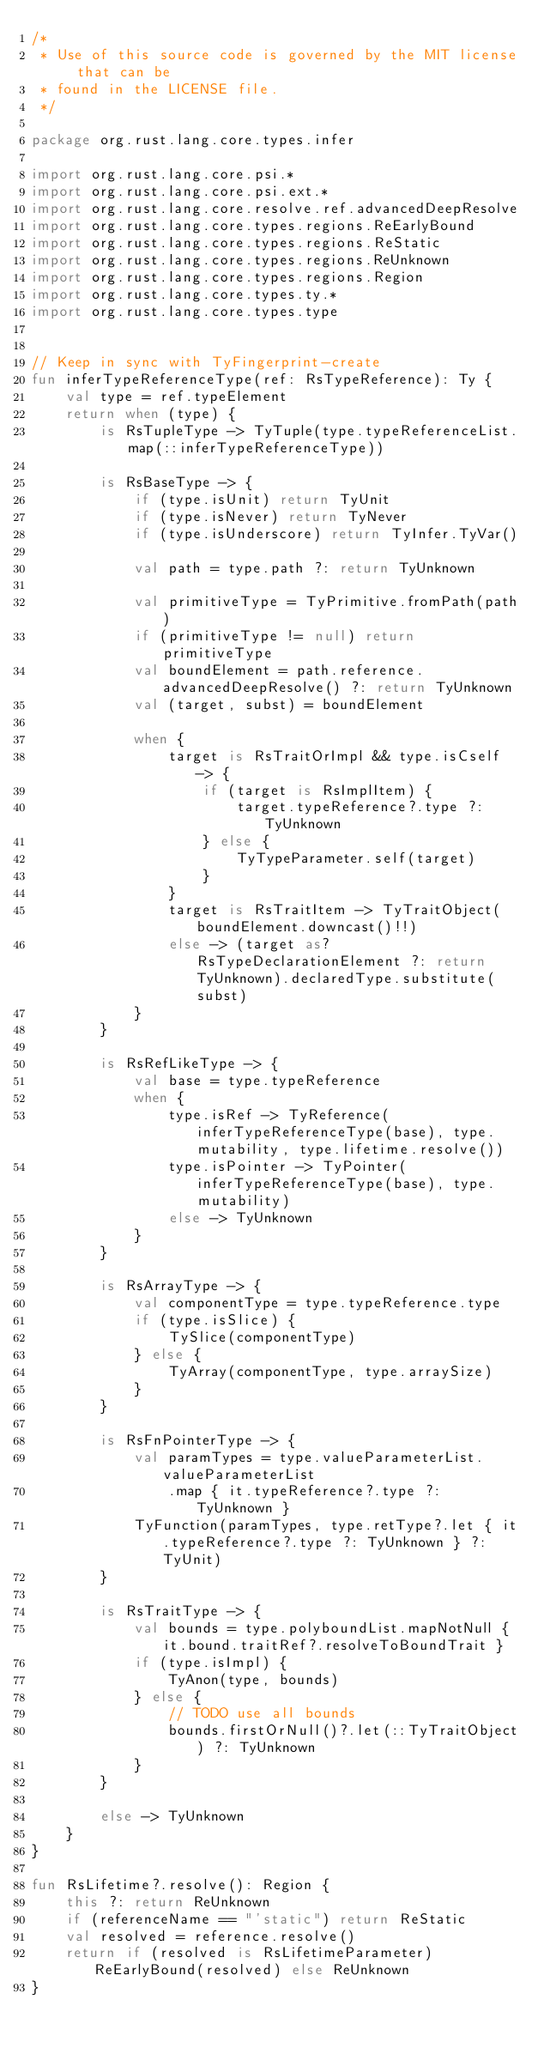<code> <loc_0><loc_0><loc_500><loc_500><_Kotlin_>/*
 * Use of this source code is governed by the MIT license that can be
 * found in the LICENSE file.
 */

package org.rust.lang.core.types.infer

import org.rust.lang.core.psi.*
import org.rust.lang.core.psi.ext.*
import org.rust.lang.core.resolve.ref.advancedDeepResolve
import org.rust.lang.core.types.regions.ReEarlyBound
import org.rust.lang.core.types.regions.ReStatic
import org.rust.lang.core.types.regions.ReUnknown
import org.rust.lang.core.types.regions.Region
import org.rust.lang.core.types.ty.*
import org.rust.lang.core.types.type


// Keep in sync with TyFingerprint-create
fun inferTypeReferenceType(ref: RsTypeReference): Ty {
    val type = ref.typeElement
    return when (type) {
        is RsTupleType -> TyTuple(type.typeReferenceList.map(::inferTypeReferenceType))

        is RsBaseType -> {
            if (type.isUnit) return TyUnit
            if (type.isNever) return TyNever
            if (type.isUnderscore) return TyInfer.TyVar()

            val path = type.path ?: return TyUnknown

            val primitiveType = TyPrimitive.fromPath(path)
            if (primitiveType != null) return primitiveType
            val boundElement = path.reference.advancedDeepResolve() ?: return TyUnknown
            val (target, subst) = boundElement

            when {
                target is RsTraitOrImpl && type.isCself -> {
                    if (target is RsImplItem) {
                        target.typeReference?.type ?: TyUnknown
                    } else {
                        TyTypeParameter.self(target)
                    }
                }
                target is RsTraitItem -> TyTraitObject(boundElement.downcast()!!)
                else -> (target as? RsTypeDeclarationElement ?: return TyUnknown).declaredType.substitute(subst)
            }
        }

        is RsRefLikeType -> {
            val base = type.typeReference
            when {
                type.isRef -> TyReference(inferTypeReferenceType(base), type.mutability, type.lifetime.resolve())
                type.isPointer -> TyPointer(inferTypeReferenceType(base), type.mutability)
                else -> TyUnknown
            }
        }

        is RsArrayType -> {
            val componentType = type.typeReference.type
            if (type.isSlice) {
                TySlice(componentType)
            } else {
                TyArray(componentType, type.arraySize)
            }
        }

        is RsFnPointerType -> {
            val paramTypes = type.valueParameterList.valueParameterList
                .map { it.typeReference?.type ?: TyUnknown }
            TyFunction(paramTypes, type.retType?.let { it.typeReference?.type ?: TyUnknown } ?: TyUnit)
        }

        is RsTraitType -> {
            val bounds = type.polyboundList.mapNotNull { it.bound.traitRef?.resolveToBoundTrait }
            if (type.isImpl) {
                TyAnon(type, bounds)
            } else {
                // TODO use all bounds
                bounds.firstOrNull()?.let(::TyTraitObject) ?: TyUnknown
            }
        }

        else -> TyUnknown
    }
}

fun RsLifetime?.resolve(): Region {
    this ?: return ReUnknown
    if (referenceName == "'static") return ReStatic
    val resolved = reference.resolve()
    return if (resolved is RsLifetimeParameter) ReEarlyBound(resolved) else ReUnknown
}
</code> 